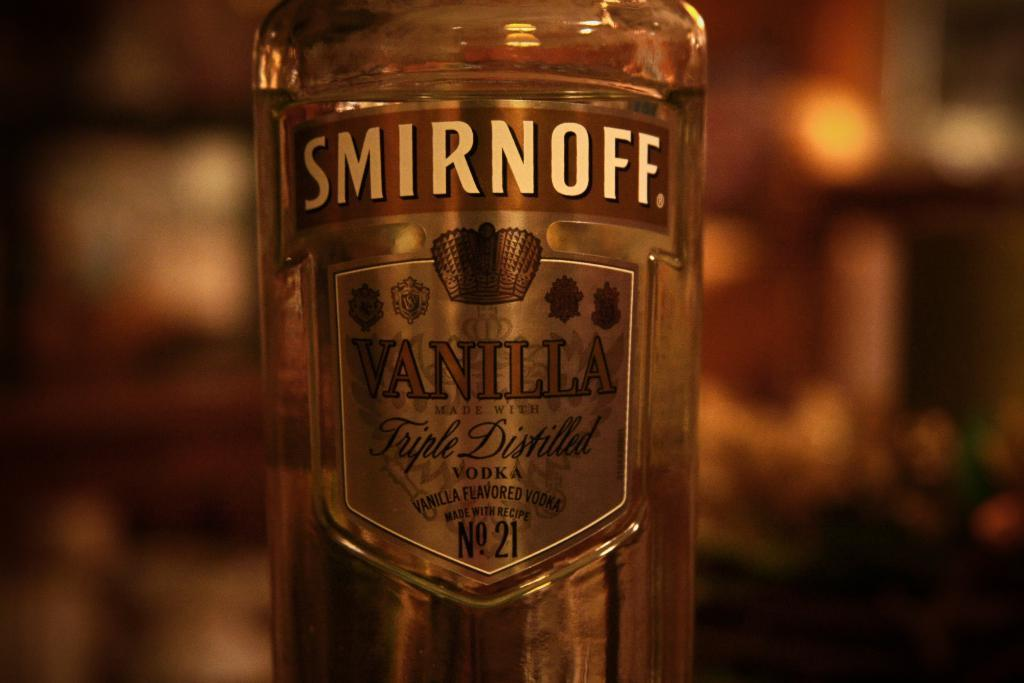<image>
Present a compact description of the photo's key features. A bottle of vodka is the Smirnoff Vanilla type. 